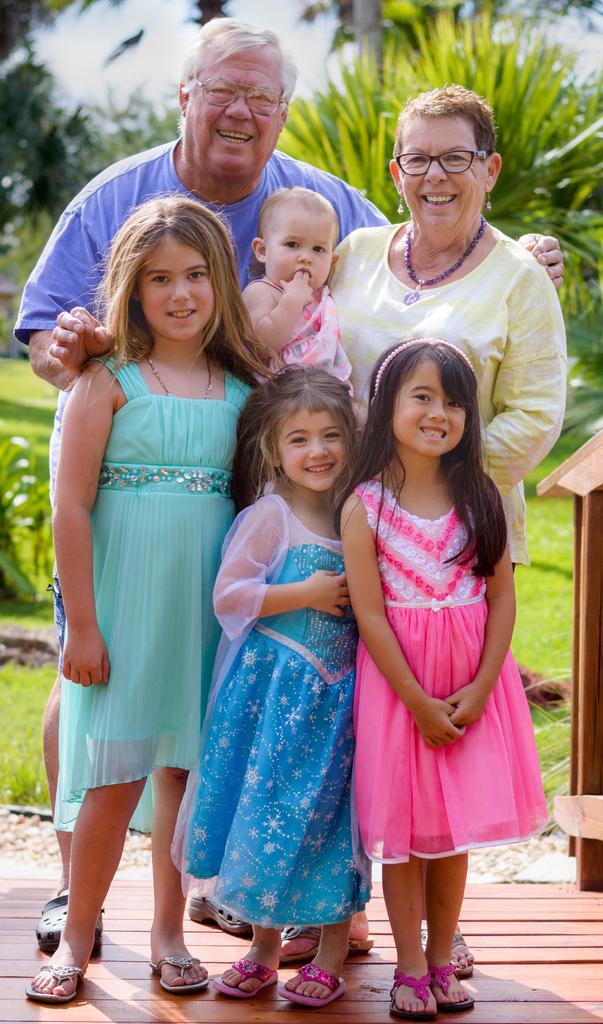How would you summarize this image in a sentence or two? In this picture we can see some people are standing on the floor and smiling. In the background we can see the grass, pants and the sky. 